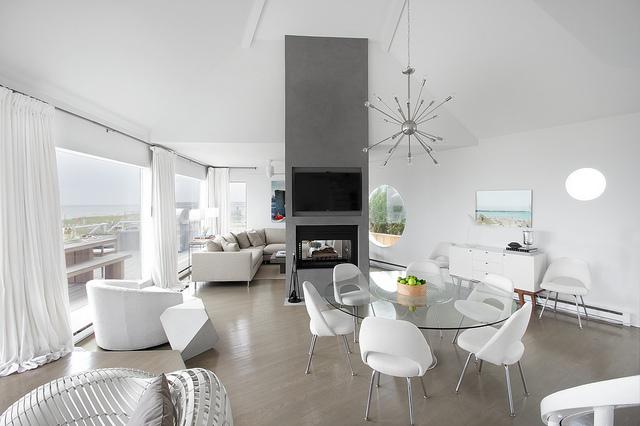What is outside the window?
Give a very brief answer. Table. Where is the television?
Keep it brief. Above fireplace. Are all the windows rectangular?
Give a very brief answer. No. 